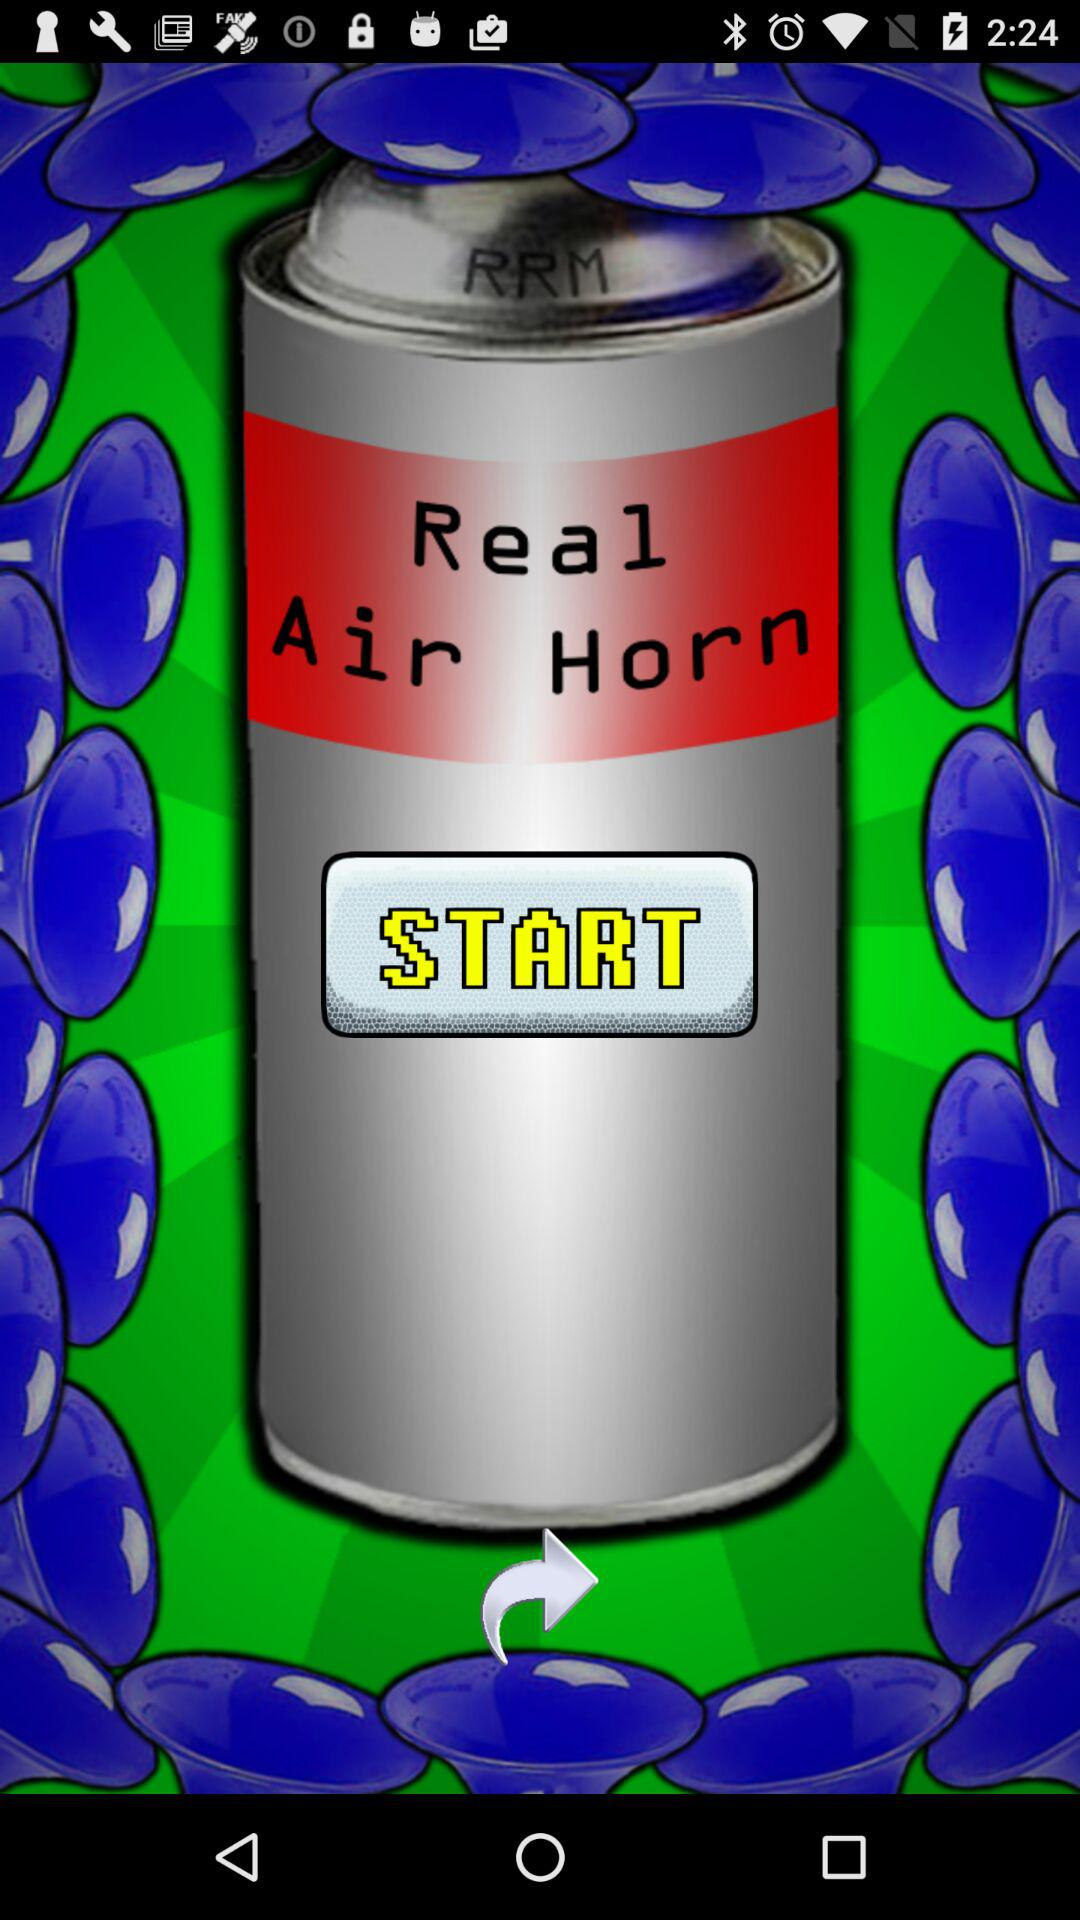What is the name of the application? The name of the application is "Real Air Horn". 